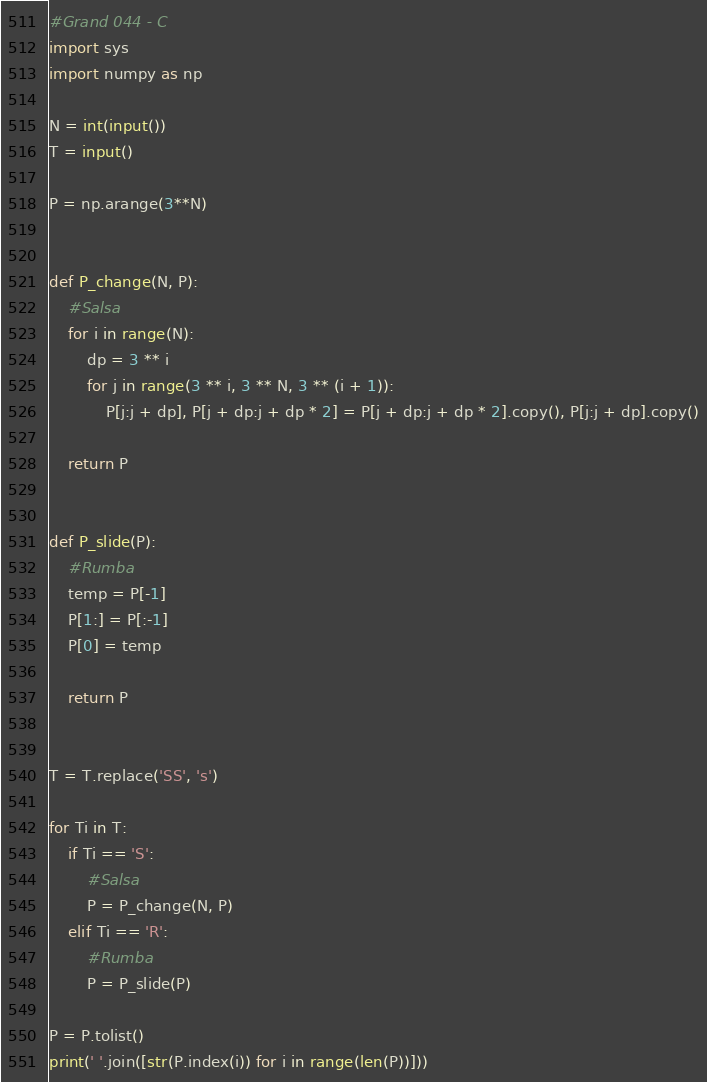<code> <loc_0><loc_0><loc_500><loc_500><_Python_>#Grand 044 - C
import sys
import numpy as np

N = int(input())
T = input()

P = np.arange(3**N)


def P_change(N, P):
    #Salsa
    for i in range(N):
        dp = 3 ** i
        for j in range(3 ** i, 3 ** N, 3 ** (i + 1)):
            P[j:j + dp], P[j + dp:j + dp * 2] = P[j + dp:j + dp * 2].copy(), P[j:j + dp].copy()
    
    return P


def P_slide(P):
    #Rumba
    temp = P[-1]
    P[1:] = P[:-1]
    P[0] = temp

    return P


T = T.replace('SS', 's')

for Ti in T:
    if Ti == 'S':
        #Salsa
        P = P_change(N, P)
    elif Ti == 'R':
        #Rumba
        P = P_slide(P)

P = P.tolist()
print(' '.join([str(P.index(i)) for i in range(len(P))]))
</code> 